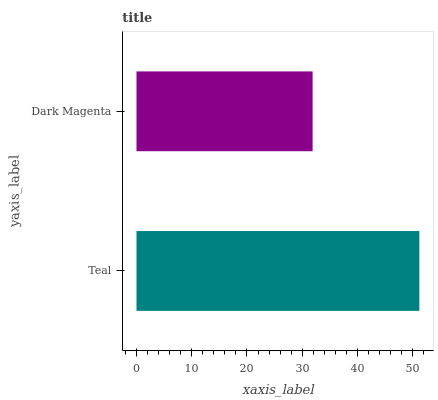Is Dark Magenta the minimum?
Answer yes or no. Yes. Is Teal the maximum?
Answer yes or no. Yes. Is Dark Magenta the maximum?
Answer yes or no. No. Is Teal greater than Dark Magenta?
Answer yes or no. Yes. Is Dark Magenta less than Teal?
Answer yes or no. Yes. Is Dark Magenta greater than Teal?
Answer yes or no. No. Is Teal less than Dark Magenta?
Answer yes or no. No. Is Teal the high median?
Answer yes or no. Yes. Is Dark Magenta the low median?
Answer yes or no. Yes. Is Dark Magenta the high median?
Answer yes or no. No. Is Teal the low median?
Answer yes or no. No. 